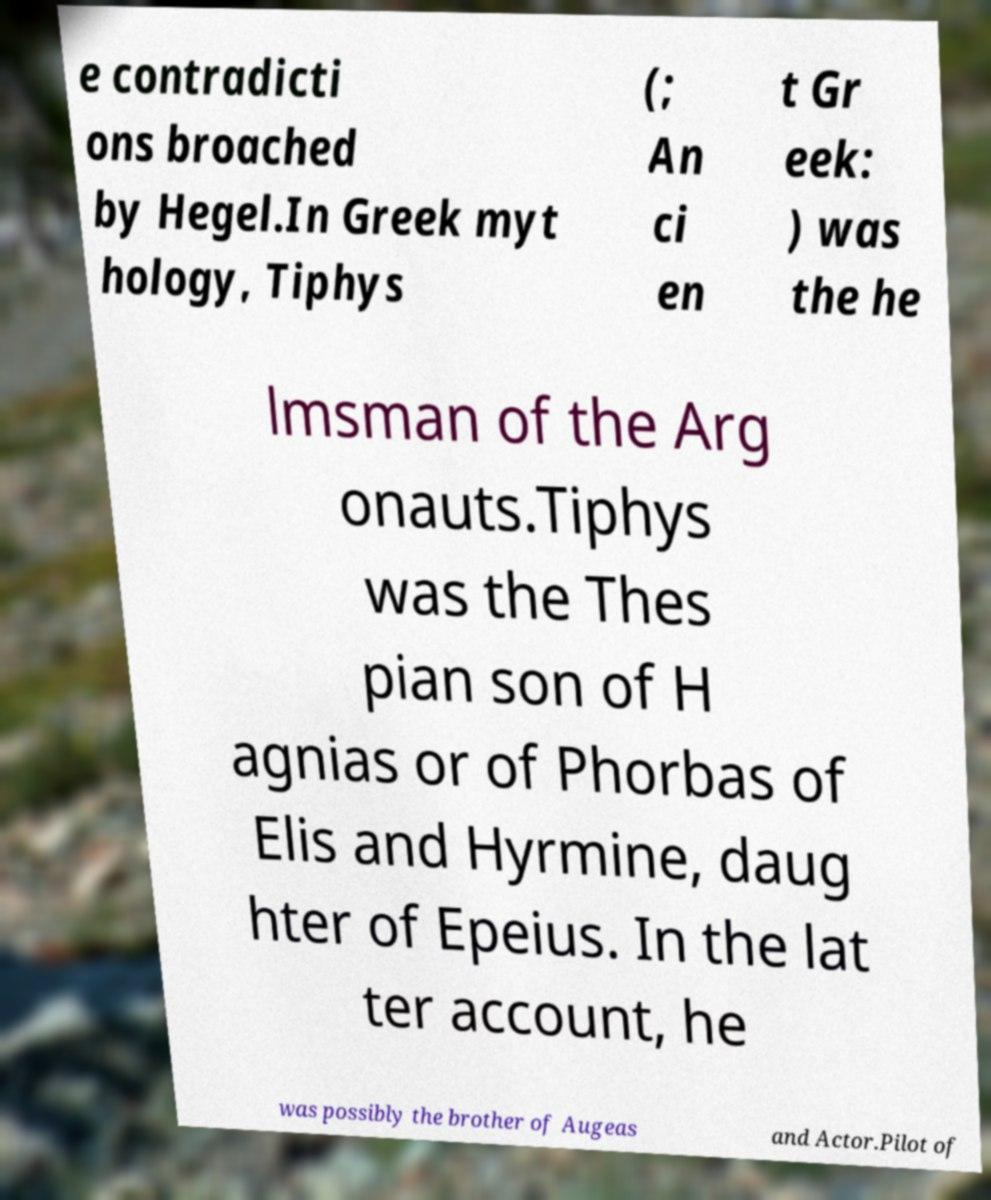Please read and relay the text visible in this image. What does it say? e contradicti ons broached by Hegel.In Greek myt hology, Tiphys (; An ci en t Gr eek: ) was the he lmsman of the Arg onauts.Tiphys was the Thes pian son of H agnias or of Phorbas of Elis and Hyrmine, daug hter of Epeius. In the lat ter account, he was possibly the brother of Augeas and Actor.Pilot of 